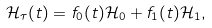Convert formula to latex. <formula><loc_0><loc_0><loc_500><loc_500>\mathcal { H } _ { \tau } ( t ) = f _ { 0 } ( t ) \mathcal { H } _ { 0 } + f _ { 1 } ( t ) \mathcal { H } _ { 1 } ,</formula> 